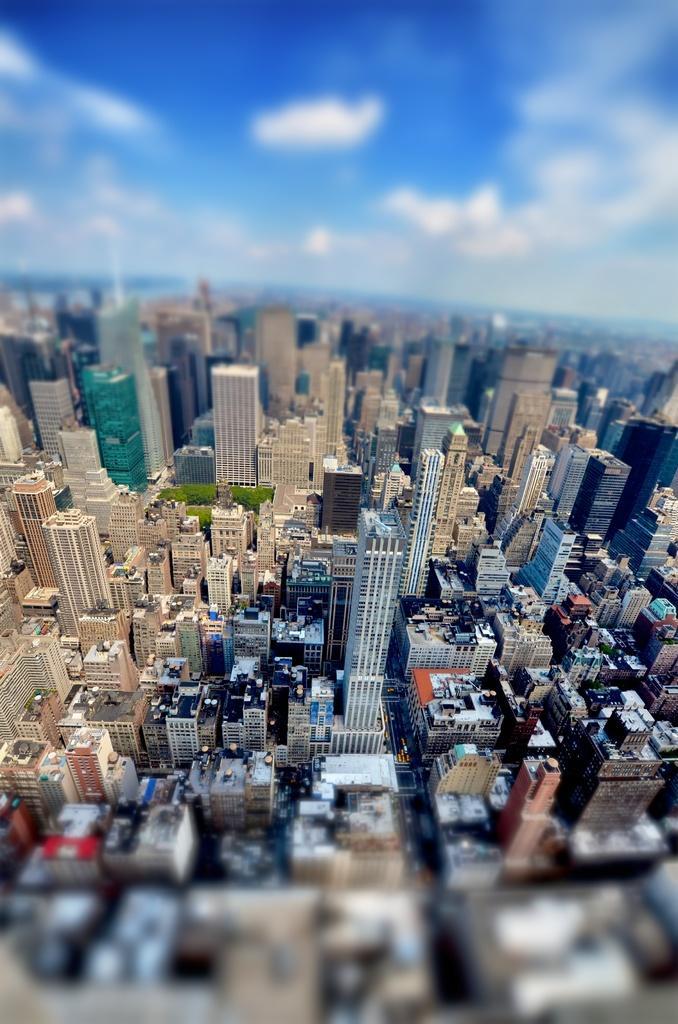Please provide a concise description of this image. In this image, there are so many buildings, vehicles, trees and roads. At the bottom and top of the image, there is a blurred view. At the top of the image, we can see the sky. 